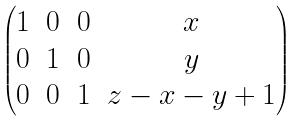Convert formula to latex. <formula><loc_0><loc_0><loc_500><loc_500>\begin{pmatrix} 1 & 0 & 0 & x \\ 0 & 1 & 0 & y \\ 0 & 0 & 1 & z - x - y + 1 \\ \end{pmatrix}</formula> 